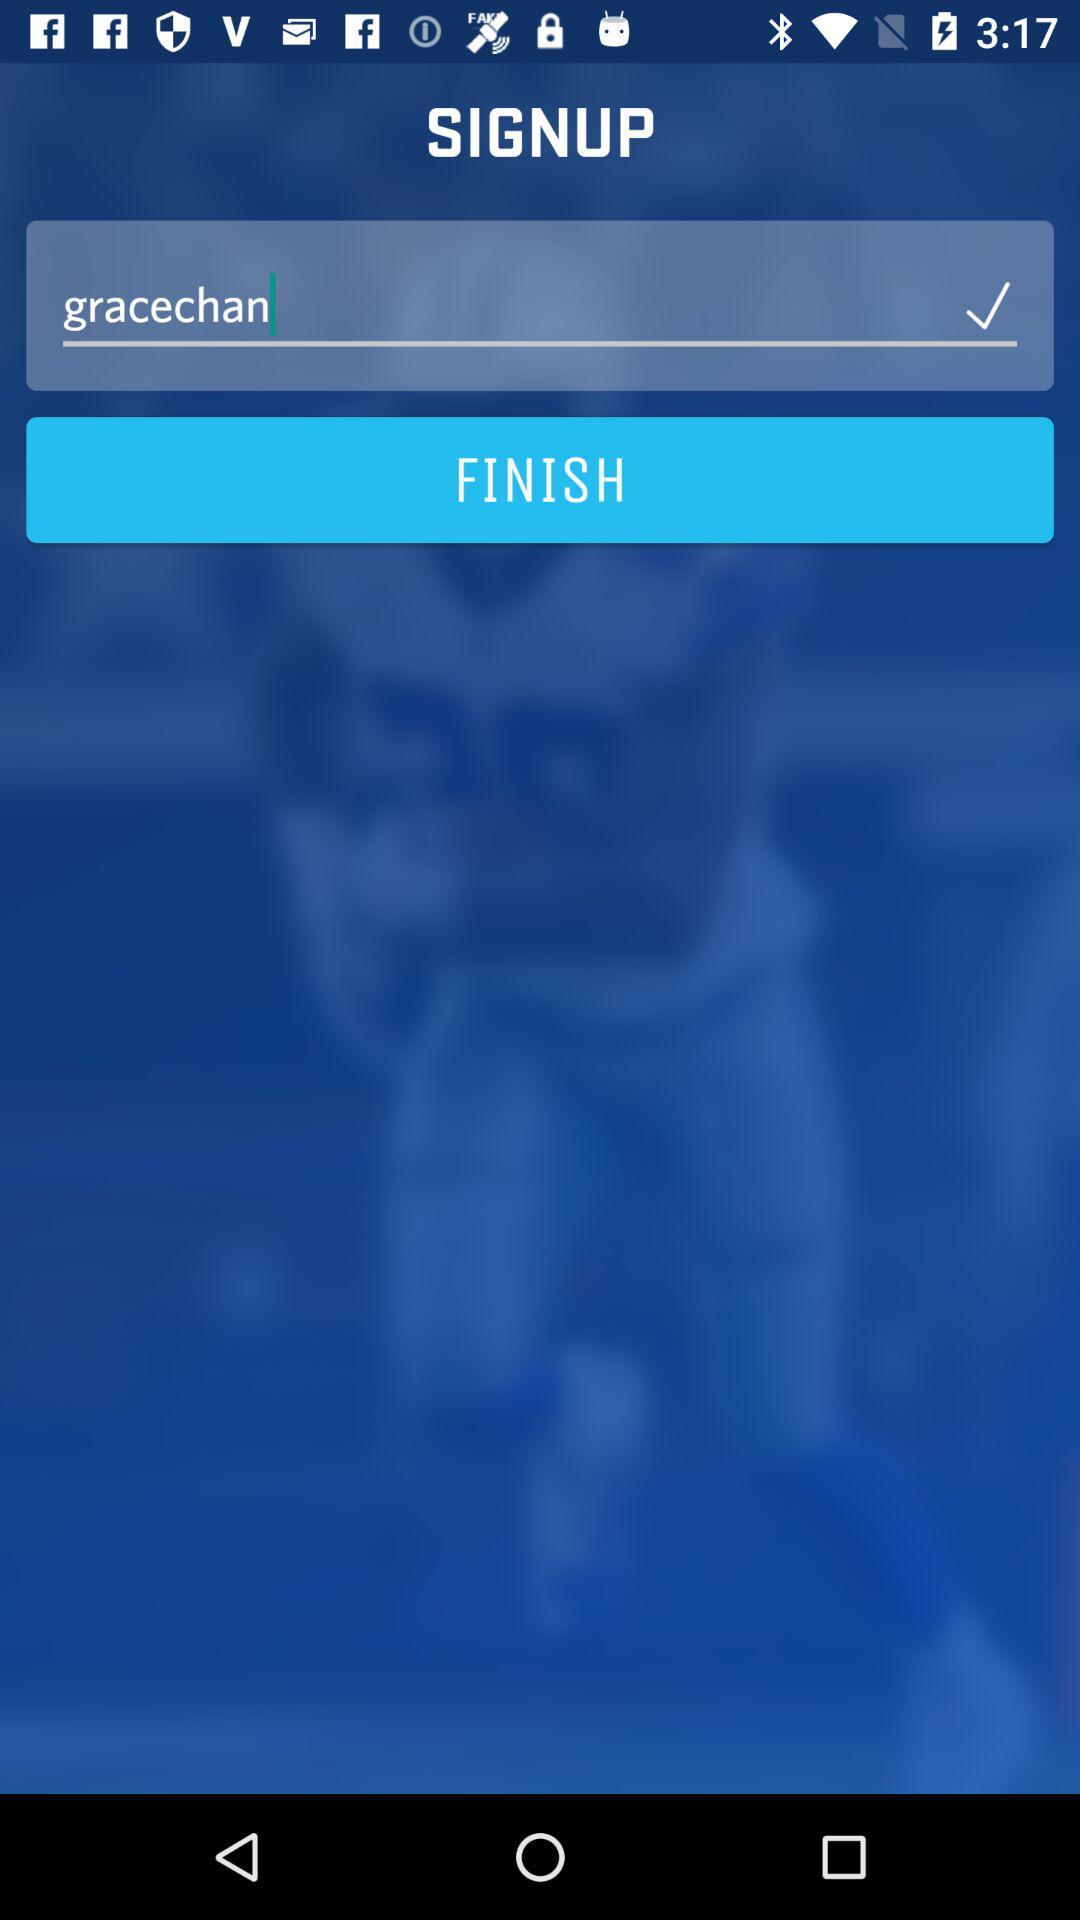What is the username? The username is "gracechan". 